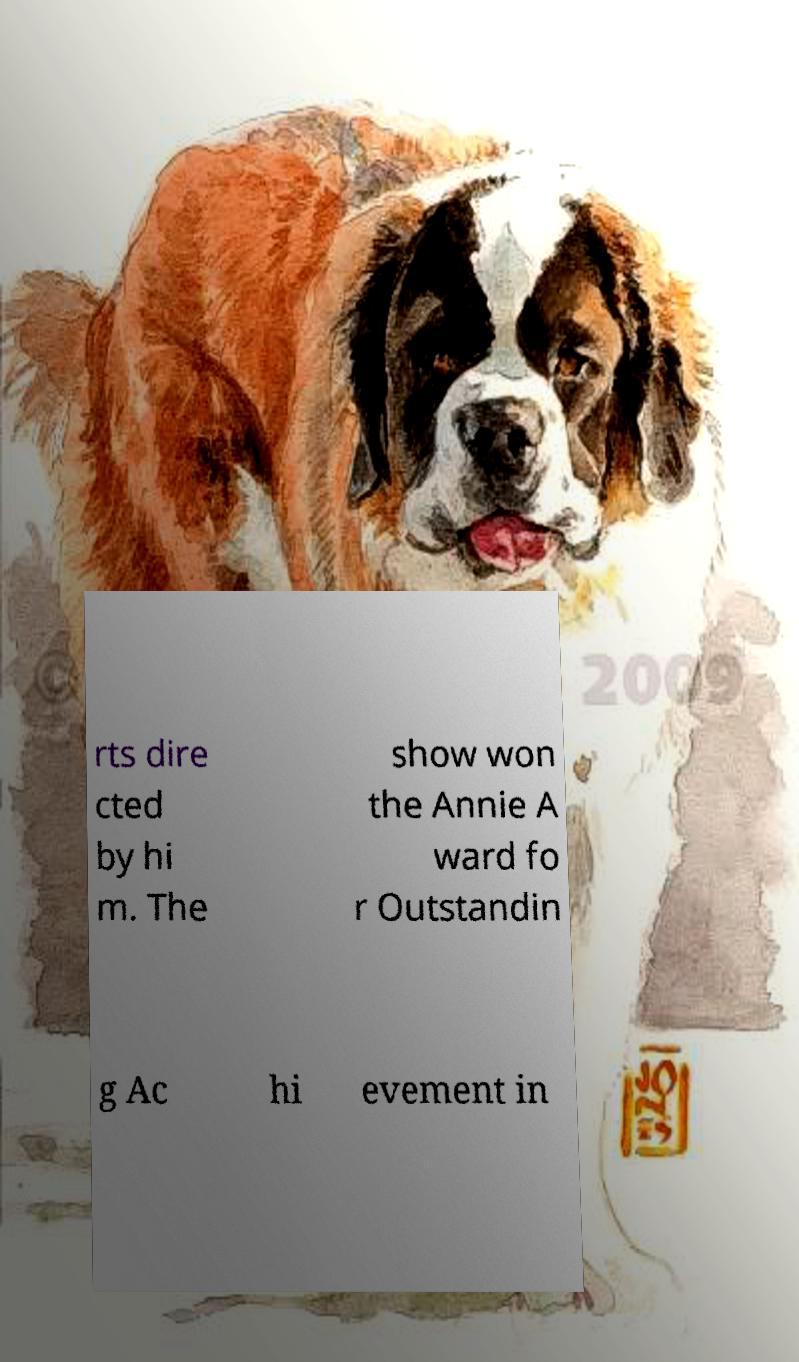What messages or text are displayed in this image? I need them in a readable, typed format. rts dire cted by hi m. The show won the Annie A ward fo r Outstandin g Ac hi evement in 